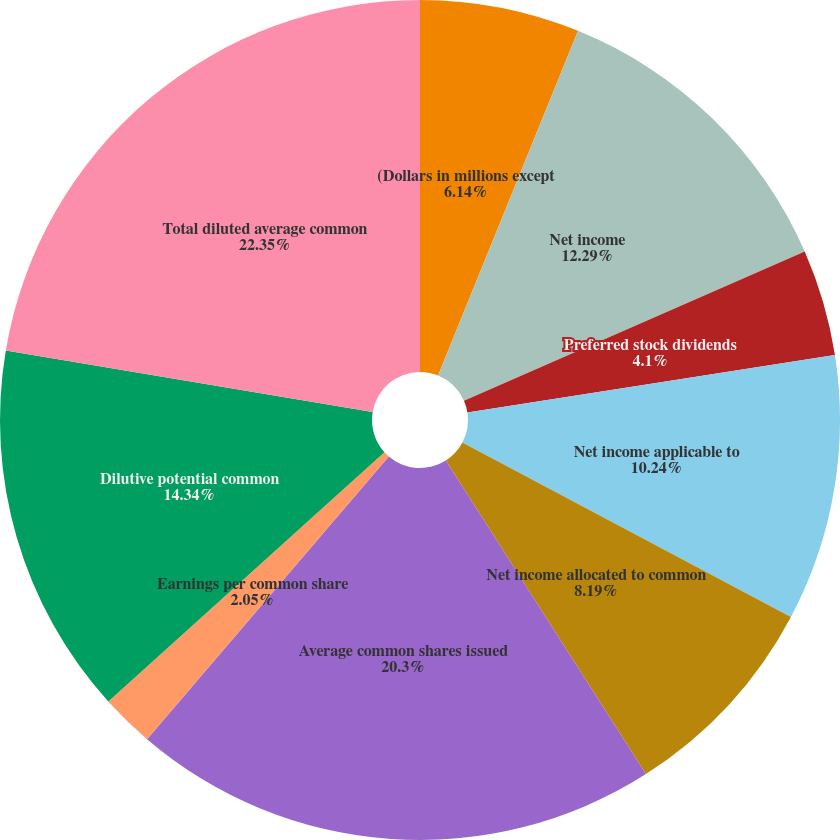Convert chart to OTSL. <chart><loc_0><loc_0><loc_500><loc_500><pie_chart><fcel>(Dollars in millions except<fcel>Net income<fcel>Preferred stock dividends<fcel>Net income applicable to<fcel>Net income allocated to common<fcel>Average common shares issued<fcel>Earnings per common share<fcel>Dilutive potential common<fcel>Total diluted average common<fcel>Diluted earnings per common<nl><fcel>6.14%<fcel>12.29%<fcel>4.1%<fcel>10.24%<fcel>8.19%<fcel>20.3%<fcel>2.05%<fcel>14.34%<fcel>22.35%<fcel>0.0%<nl></chart> 